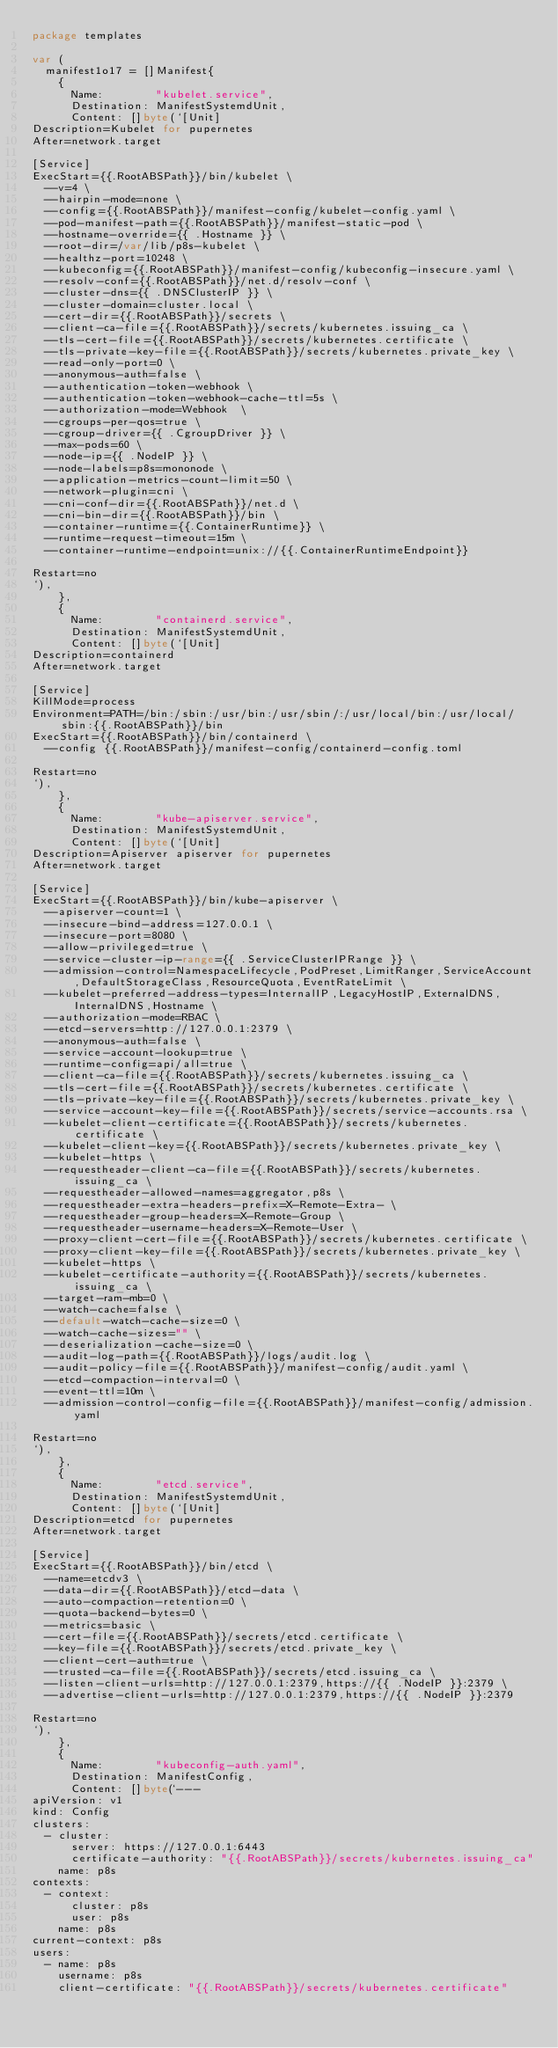<code> <loc_0><loc_0><loc_500><loc_500><_Go_>package templates

var (
	manifest1o17 = []Manifest{
		{
			Name:        "kubelet.service",
			Destination: ManifestSystemdUnit,
			Content: []byte(`[Unit]
Description=Kubelet for pupernetes
After=network.target

[Service]
ExecStart={{.RootABSPath}}/bin/kubelet \
  --v=4 \
  --hairpin-mode=none \
  --config={{.RootABSPath}}/manifest-config/kubelet-config.yaml \
	--pod-manifest-path={{.RootABSPath}}/manifest-static-pod \
	--hostname-override={{ .Hostname }} \
	--root-dir=/var/lib/p8s-kubelet \
	--healthz-port=10248 \
	--kubeconfig={{.RootABSPath}}/manifest-config/kubeconfig-insecure.yaml \
	--resolv-conf={{.RootABSPath}}/net.d/resolv-conf \
	--cluster-dns={{ .DNSClusterIP }} \
	--cluster-domain=cluster.local \
	--cert-dir={{.RootABSPath}}/secrets \
	--client-ca-file={{.RootABSPath}}/secrets/kubernetes.issuing_ca \
	--tls-cert-file={{.RootABSPath}}/secrets/kubernetes.certificate \
	--tls-private-key-file={{.RootABSPath}}/secrets/kubernetes.private_key \
	--read-only-port=0 \
	--anonymous-auth=false \
	--authentication-token-webhook \
	--authentication-token-webhook-cache-ttl=5s \
	--authorization-mode=Webhook  \
	--cgroups-per-qos=true \
	--cgroup-driver={{ .CgroupDriver }} \
	--max-pods=60 \
	--node-ip={{ .NodeIP }} \
	--node-labels=p8s=mononode \
	--application-metrics-count-limit=50 \
	--network-plugin=cni \
	--cni-conf-dir={{.RootABSPath}}/net.d \
	--cni-bin-dir={{.RootABSPath}}/bin \
	--container-runtime={{.ContainerRuntime}} \
	--runtime-request-timeout=15m \
	--container-runtime-endpoint=unix://{{.ContainerRuntimeEndpoint}}

Restart=no
`),
		},
		{
			Name:        "containerd.service",
			Destination: ManifestSystemdUnit,
			Content: []byte(`[Unit]
Description=containerd
After=network.target

[Service]
KillMode=process
Environment=PATH=/bin:/sbin:/usr/bin:/usr/sbin/:/usr/local/bin:/usr/local/sbin:{{.RootABSPath}}/bin
ExecStart={{.RootABSPath}}/bin/containerd \
	--config {{.RootABSPath}}/manifest-config/containerd-config.toml

Restart=no
`),
		},
		{
			Name:        "kube-apiserver.service",
			Destination: ManifestSystemdUnit,
			Content: []byte(`[Unit]
Description=Apiserver apiserver for pupernetes
After=network.target

[Service]
ExecStart={{.RootABSPath}}/bin/kube-apiserver \
	--apiserver-count=1 \
	--insecure-bind-address=127.0.0.1 \
	--insecure-port=8080 \
	--allow-privileged=true \
	--service-cluster-ip-range={{ .ServiceClusterIPRange }} \
	--admission-control=NamespaceLifecycle,PodPreset,LimitRanger,ServiceAccount,DefaultStorageClass,ResourceQuota,EventRateLimit \
	--kubelet-preferred-address-types=InternalIP,LegacyHostIP,ExternalDNS,InternalDNS,Hostname \
	--authorization-mode=RBAC \
	--etcd-servers=http://127.0.0.1:2379 \
	--anonymous-auth=false \
	--service-account-lookup=true \
	--runtime-config=api/all=true \
	--client-ca-file={{.RootABSPath}}/secrets/kubernetes.issuing_ca \
	--tls-cert-file={{.RootABSPath}}/secrets/kubernetes.certificate \
	--tls-private-key-file={{.RootABSPath}}/secrets/kubernetes.private_key \
	--service-account-key-file={{.RootABSPath}}/secrets/service-accounts.rsa \
	--kubelet-client-certificate={{.RootABSPath}}/secrets/kubernetes.certificate \
	--kubelet-client-key={{.RootABSPath}}/secrets/kubernetes.private_key \
	--kubelet-https \
	--requestheader-client-ca-file={{.RootABSPath}}/secrets/kubernetes.issuing_ca \
	--requestheader-allowed-names=aggregator,p8s \
	--requestheader-extra-headers-prefix=X-Remote-Extra- \
	--requestheader-group-headers=X-Remote-Group \
	--requestheader-username-headers=X-Remote-User \
	--proxy-client-cert-file={{.RootABSPath}}/secrets/kubernetes.certificate \
	--proxy-client-key-file={{.RootABSPath}}/secrets/kubernetes.private_key \
	--kubelet-https \
	--kubelet-certificate-authority={{.RootABSPath}}/secrets/kubernetes.issuing_ca \
	--target-ram-mb=0 \
	--watch-cache=false \
	--default-watch-cache-size=0 \
	--watch-cache-sizes="" \
	--deserialization-cache-size=0 \
	--audit-log-path={{.RootABSPath}}/logs/audit.log \
	--audit-policy-file={{.RootABSPath}}/manifest-config/audit.yaml \
	--etcd-compaction-interval=0 \
	--event-ttl=10m \
	--admission-control-config-file={{.RootABSPath}}/manifest-config/admission.yaml

Restart=no
`),
		},
		{
			Name:        "etcd.service",
			Destination: ManifestSystemdUnit,
			Content: []byte(`[Unit]
Description=etcd for pupernetes
After=network.target

[Service]
ExecStart={{.RootABSPath}}/bin/etcd \
	--name=etcdv3 \
	--data-dir={{.RootABSPath}}/etcd-data \
	--auto-compaction-retention=0 \
	--quota-backend-bytes=0 \
	--metrics=basic \
	--cert-file={{.RootABSPath}}/secrets/etcd.certificate \
	--key-file={{.RootABSPath}}/secrets/etcd.private_key \
	--client-cert-auth=true \
	--trusted-ca-file={{.RootABSPath}}/secrets/etcd.issuing_ca \
	--listen-client-urls=http://127.0.0.1:2379,https://{{ .NodeIP }}:2379 \
	--advertise-client-urls=http://127.0.0.1:2379,https://{{ .NodeIP }}:2379

Restart=no
`),
		},
		{
			Name:        "kubeconfig-auth.yaml",
			Destination: ManifestConfig,
			Content: []byte(`---
apiVersion: v1
kind: Config
clusters:
  - cluster:
      server: https://127.0.0.1:6443
      certificate-authority: "{{.RootABSPath}}/secrets/kubernetes.issuing_ca"
    name: p8s
contexts:
  - context:
      cluster: p8s
      user: p8s
    name: p8s
current-context: p8s
users:
  - name: p8s
    username: p8s
    client-certificate: "{{.RootABSPath}}/secrets/kubernetes.certificate"</code> 